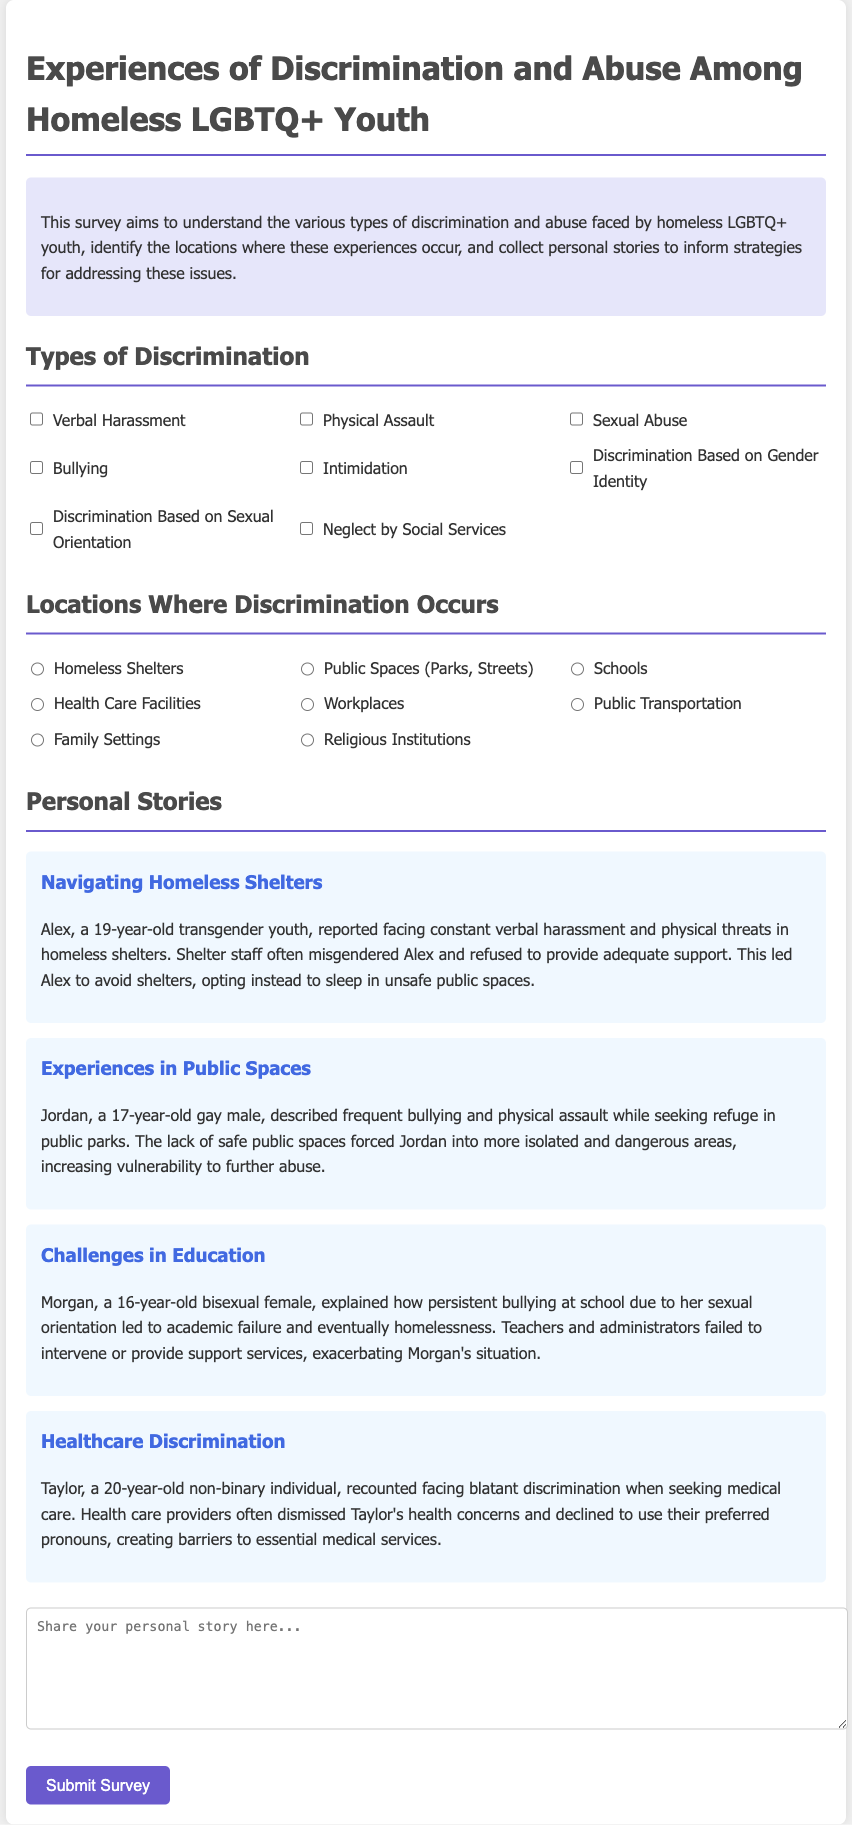What is the purpose of the survey? The purpose of the survey is to understand the various types of discrimination and abuse faced by homeless LGBTQ+ youth, identify the locations where these experiences occur, and collect personal stories.
Answer: Understanding discrimination and abuse How many types of discrimination are listed? The document lists eight different types of discrimination faced by homeless LGBTQ+ youth.
Answer: Eight What location is mentioned where discrimination occurs? The survey provides a radio button selection for several locations, one of which is 'Homeless Shelters'.
Answer: Homeless Shelters Who is the subject of the story about healthcare discrimination? The story about healthcare discrimination features Taylor, a 20-year-old non-binary individual.
Answer: Taylor What type of discrimination did Alex experience? Alex reported facing constant verbal harassment and physical threats in homeless shelters.
Answer: Verbal harassment and physical threats What is the age of Morgan mentioned in the challenges in education story? Morgan, who explained her experiences in the education system, is 16 years old.
Answer: 16 What type of abuse did Jordan describe in public spaces? Jordan described experiences of frequent bullying and physical assault while in public parks.
Answer: Bullying and physical assault What is the survey's format for collecting personal stories? The survey collects personal stories through an open-text area where respondents can share their experiences.
Answer: Open-text area 